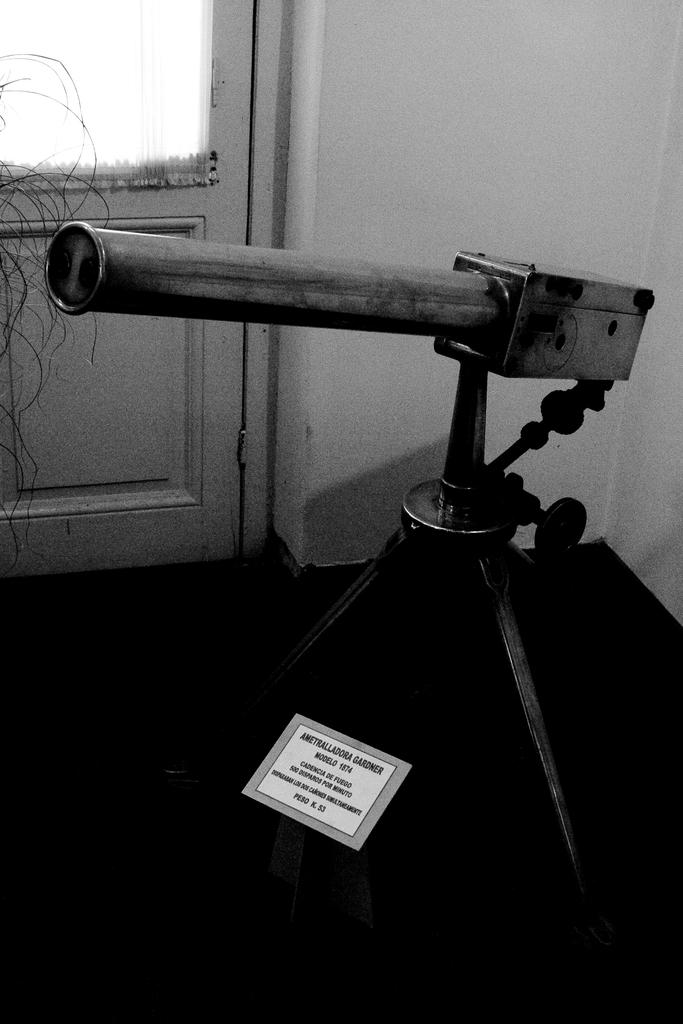What is the color scheme of the image? The image is black and white. What is the main object in the image? There is an object on a stand in the image. What is on the floor in the image? There is a tag on the floor in the image. What can be seen in the background of the image? There is a door and a wall visible in the background of the image. What type of honey is being poured into the glass in the image? There is no glass or honey present in the image; it is a black and white image with an object on a stand, a tag on the floor, and a door and wall in the background. How is the lock on the door in the image being used? There is no lock visible in the image; only a door and a wall are present in the background. 